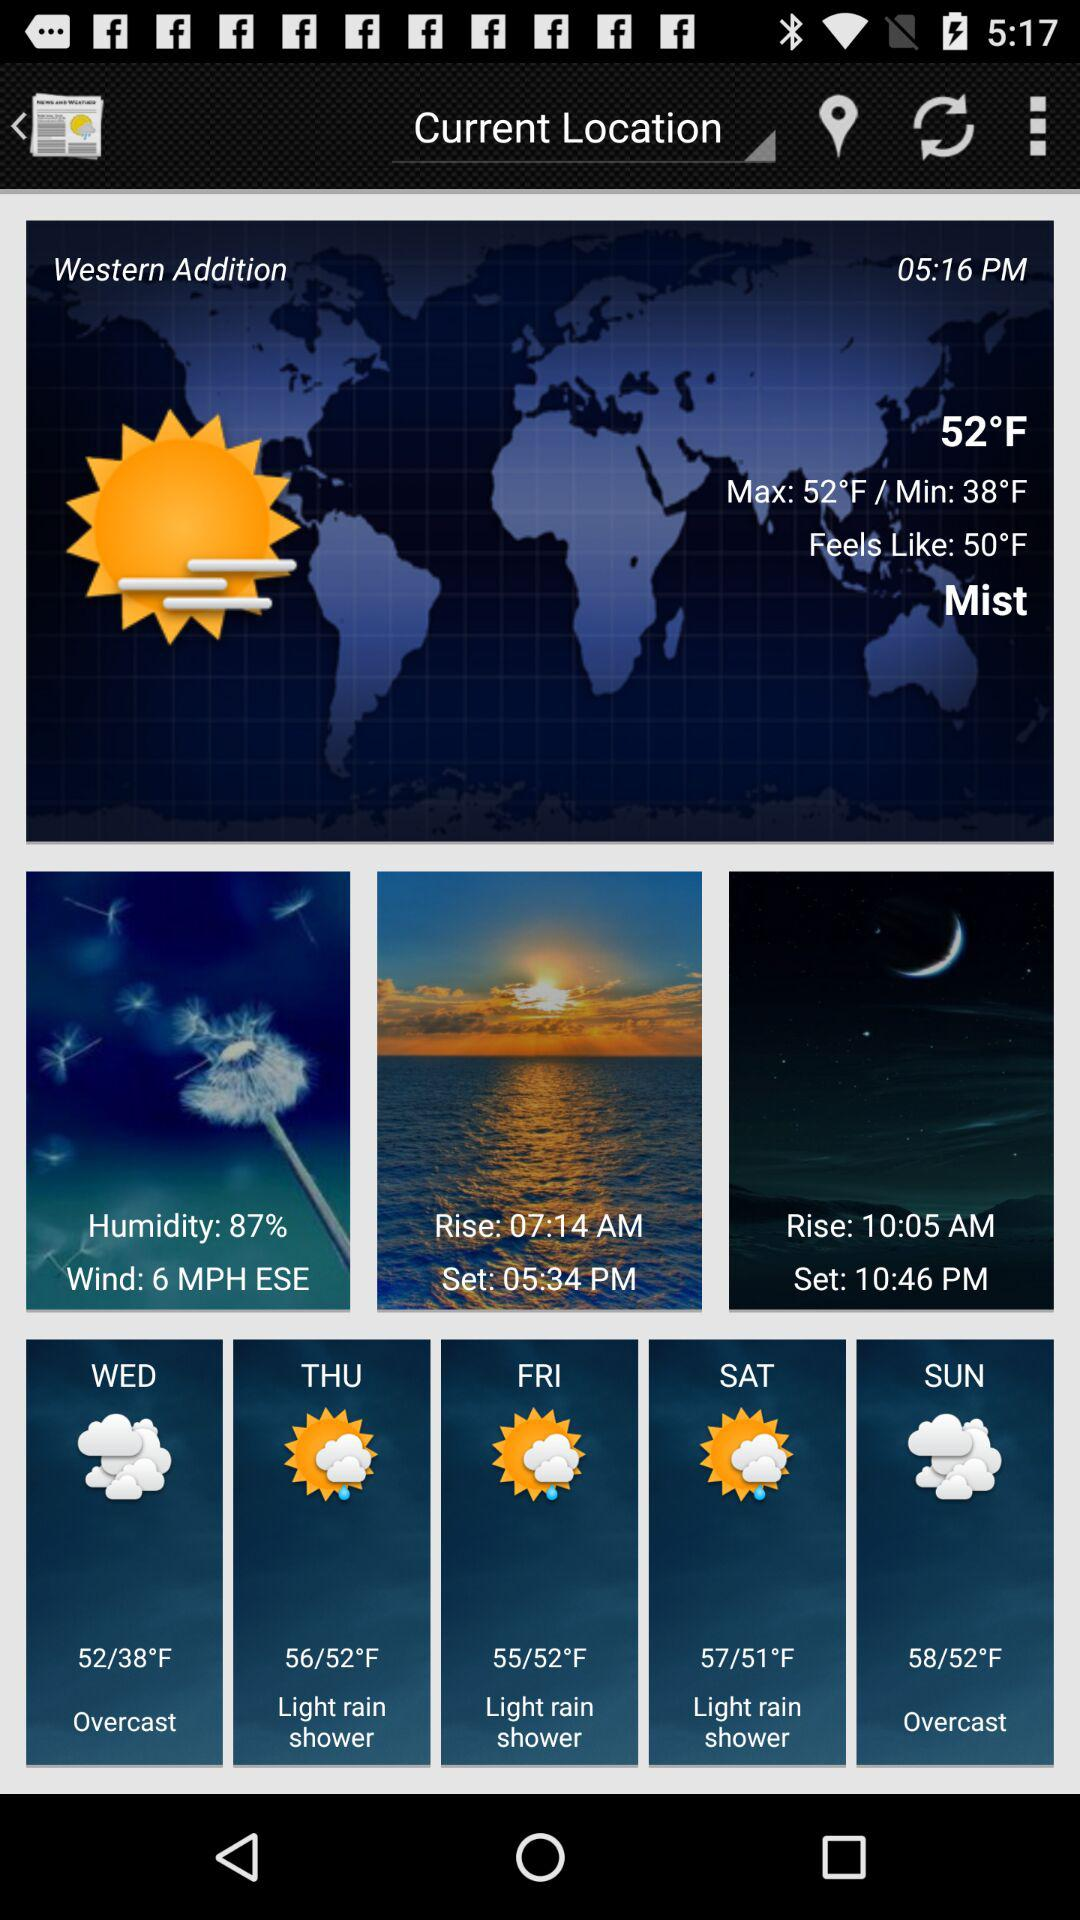What is the time of sunrise? The time of sunrise is 07:14 AM. 